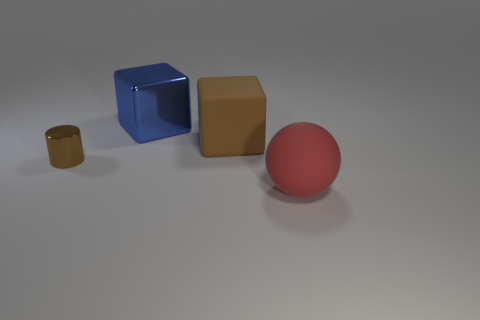Are there any other things that are the same size as the brown metal object?
Give a very brief answer. No. What material is the small brown cylinder?
Your answer should be very brief. Metal. Are there any objects left of the blue metal cube?
Offer a terse response. Yes. Does the red rubber thing have the same shape as the blue shiny thing?
Provide a succinct answer. No. What number of other things are there of the same size as the brown rubber object?
Make the answer very short. 2. How many objects are either objects that are in front of the large brown rubber thing or large cyan metal spheres?
Provide a succinct answer. 2. The cylinder has what color?
Offer a very short reply. Brown. What is the brown object on the right side of the large blue metal thing made of?
Provide a short and direct response. Rubber. Is the shape of the blue thing the same as the brown thing that is on the right side of the tiny brown metal thing?
Keep it short and to the point. Yes. Are there more objects than gray rubber cylinders?
Offer a very short reply. Yes. 